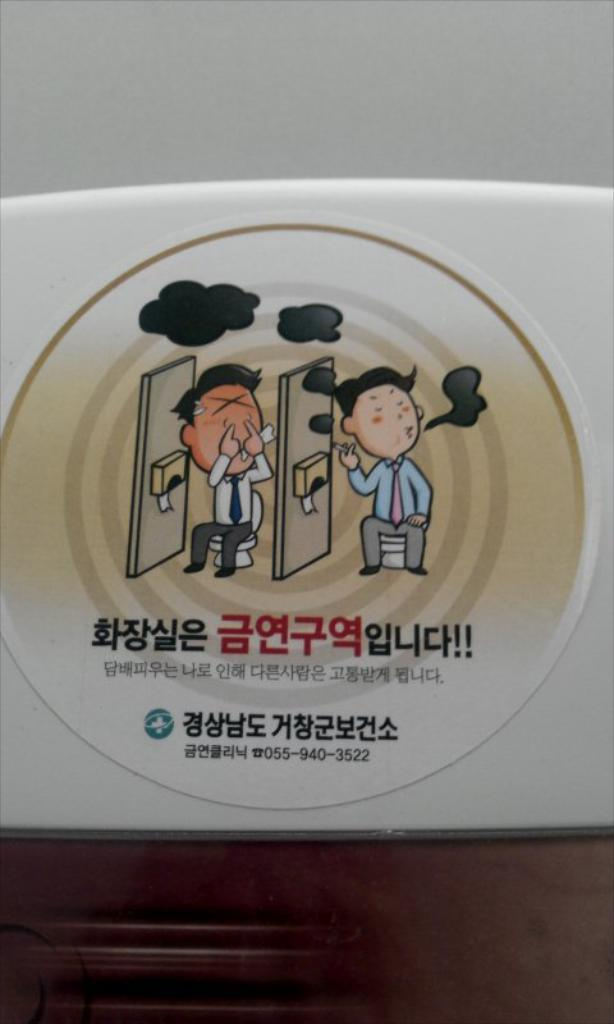What is the white object with a sticker on it in the image? There is a sticker on a white object in the image, but the specific object is not mentioned. What is depicted on the sticker? The sticker features two persons sitting on toilet seats. How many pears are sitting on the pan in the image? There are no pears or pans present in the image. The sticker features two persons sitting on toilet seats, not pears or pans. 